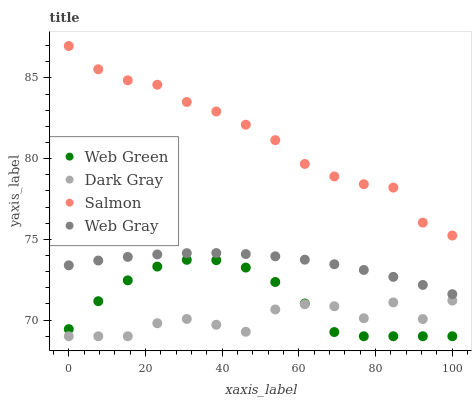Does Dark Gray have the minimum area under the curve?
Answer yes or no. Yes. Does Salmon have the maximum area under the curve?
Answer yes or no. Yes. Does Web Gray have the minimum area under the curve?
Answer yes or no. No. Does Web Gray have the maximum area under the curve?
Answer yes or no. No. Is Web Gray the smoothest?
Answer yes or no. Yes. Is Dark Gray the roughest?
Answer yes or no. Yes. Is Salmon the smoothest?
Answer yes or no. No. Is Salmon the roughest?
Answer yes or no. No. Does Dark Gray have the lowest value?
Answer yes or no. Yes. Does Web Gray have the lowest value?
Answer yes or no. No. Does Salmon have the highest value?
Answer yes or no. Yes. Does Web Gray have the highest value?
Answer yes or no. No. Is Web Green less than Web Gray?
Answer yes or no. Yes. Is Salmon greater than Dark Gray?
Answer yes or no. Yes. Does Web Green intersect Dark Gray?
Answer yes or no. Yes. Is Web Green less than Dark Gray?
Answer yes or no. No. Is Web Green greater than Dark Gray?
Answer yes or no. No. Does Web Green intersect Web Gray?
Answer yes or no. No. 